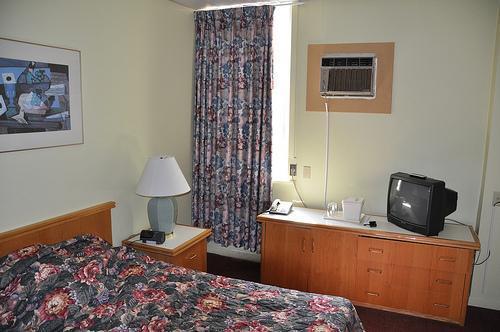How many TVs are in the photo?
Give a very brief answer. 1. How many beds are there?
Give a very brief answer. 1. 